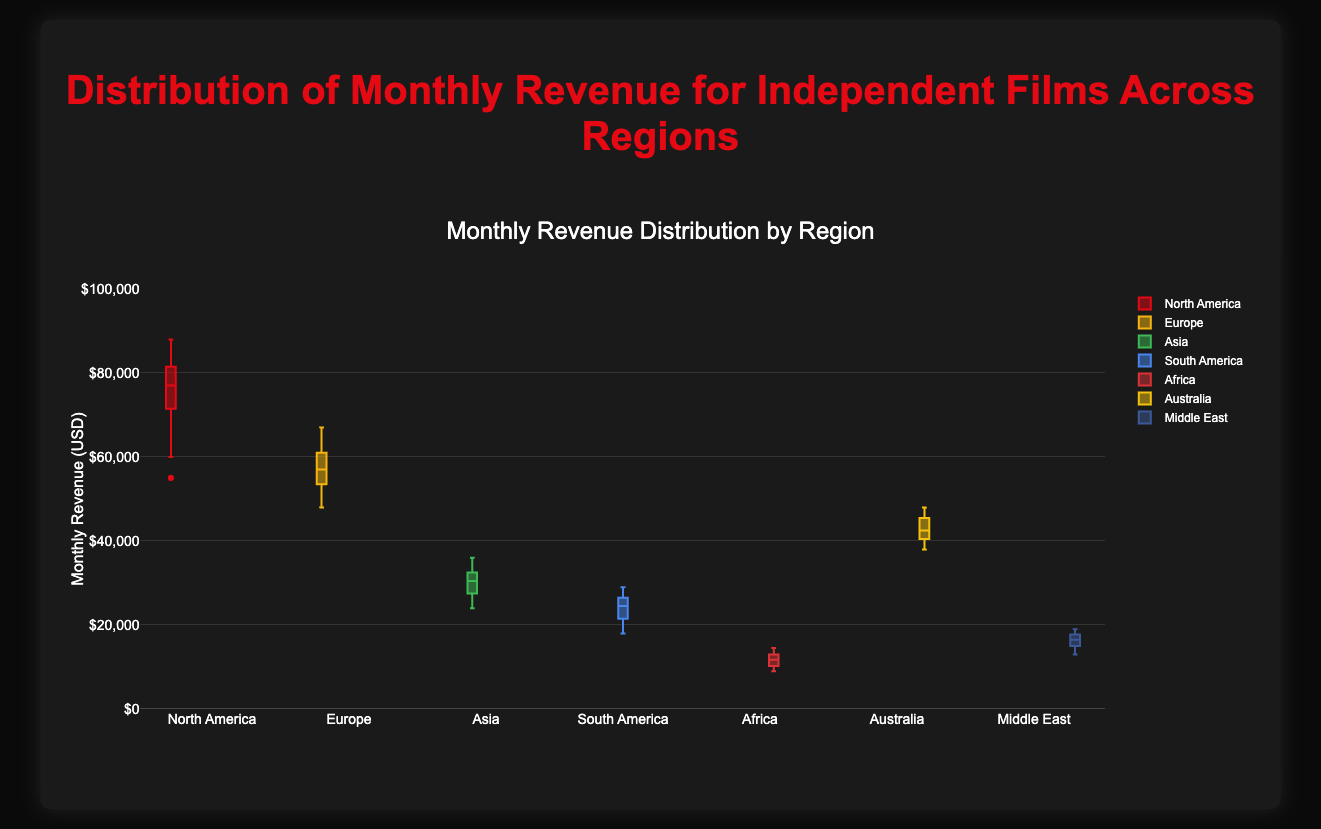What is the color used for the North America box plot? The North America box plot is the first one in the legend and the color associated with North America can be identified visually from the figure.
Answer: red What is the maximum monthly revenue for independent films in Africa? To find the maximum monthly revenue for Africa, look for the highest point on the box plot labeled "Africa". The upper whisker or the highest outlier will represent the maximum value.
Answer: 14500 Which region has the highest median monthly revenue? The median is represented by the line inside the box of each plot. By comparing the medians from each region, we can see which one is the highest. Check all medians to find the highest.
Answer: North America In which region do independent films have the most spread in monthly revenue? The spread can be determined by looking at the interquartile range (IQR), which is the box height. The region with the widest box has the most spread in monthly revenue.
Answer: North America What is the interquartile range (IQR) for Europe? The IQR is the range between the first quartile (Q1) and the third quartile (Q3). On a box plot, this is represented by the lower and upper edges of the box. Identify Q1 and Q3 from the Europe box plot and subtract Q1 from Q3.
Answer: 12000 (65000-53000) Which region has the lowest minimum monthly revenue? The minimum monthly revenue can be found by looking at the lowest whisker or outlier point for each box plot. Determine which region's minimum is the smallest.
Answer: Africa Compare the median monthly revenues of Asia and South America. Which is higher? To compare the median monthly revenues, look at the lines inside the boxes for both Asia and South America. Identify which median line is higher.
Answer: Asia What region has the largest outlier in terms of monthly revenue? Outliers are plotted as individual points outside the whiskers. The largest outlier can be found by identifying the highest outlier point across all regions.
Answer: North America What is the median monthly revenue for Middle East? The median monthly revenue is represented by the line inside the box in the "Middle East" box plot. Identify this line's value.
Answer: 16000 How does the median monthly revenue in Australia compare to that in Europe? Compare the median lines of the Australia and Europe box plots to determine which is higher or if they are the same.
Answer: Australia 